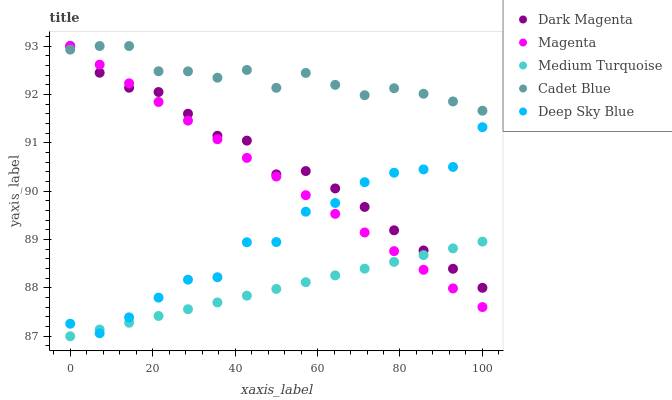Does Medium Turquoise have the minimum area under the curve?
Answer yes or no. Yes. Does Cadet Blue have the maximum area under the curve?
Answer yes or no. Yes. Does Magenta have the minimum area under the curve?
Answer yes or no. No. Does Magenta have the maximum area under the curve?
Answer yes or no. No. Is Magenta the smoothest?
Answer yes or no. Yes. Is Deep Sky Blue the roughest?
Answer yes or no. Yes. Is Cadet Blue the smoothest?
Answer yes or no. No. Is Cadet Blue the roughest?
Answer yes or no. No. Does Medium Turquoise have the lowest value?
Answer yes or no. Yes. Does Magenta have the lowest value?
Answer yes or no. No. Does Dark Magenta have the highest value?
Answer yes or no. Yes. Does Medium Turquoise have the highest value?
Answer yes or no. No. Is Medium Turquoise less than Cadet Blue?
Answer yes or no. Yes. Is Cadet Blue greater than Deep Sky Blue?
Answer yes or no. Yes. Does Medium Turquoise intersect Deep Sky Blue?
Answer yes or no. Yes. Is Medium Turquoise less than Deep Sky Blue?
Answer yes or no. No. Is Medium Turquoise greater than Deep Sky Blue?
Answer yes or no. No. Does Medium Turquoise intersect Cadet Blue?
Answer yes or no. No. 